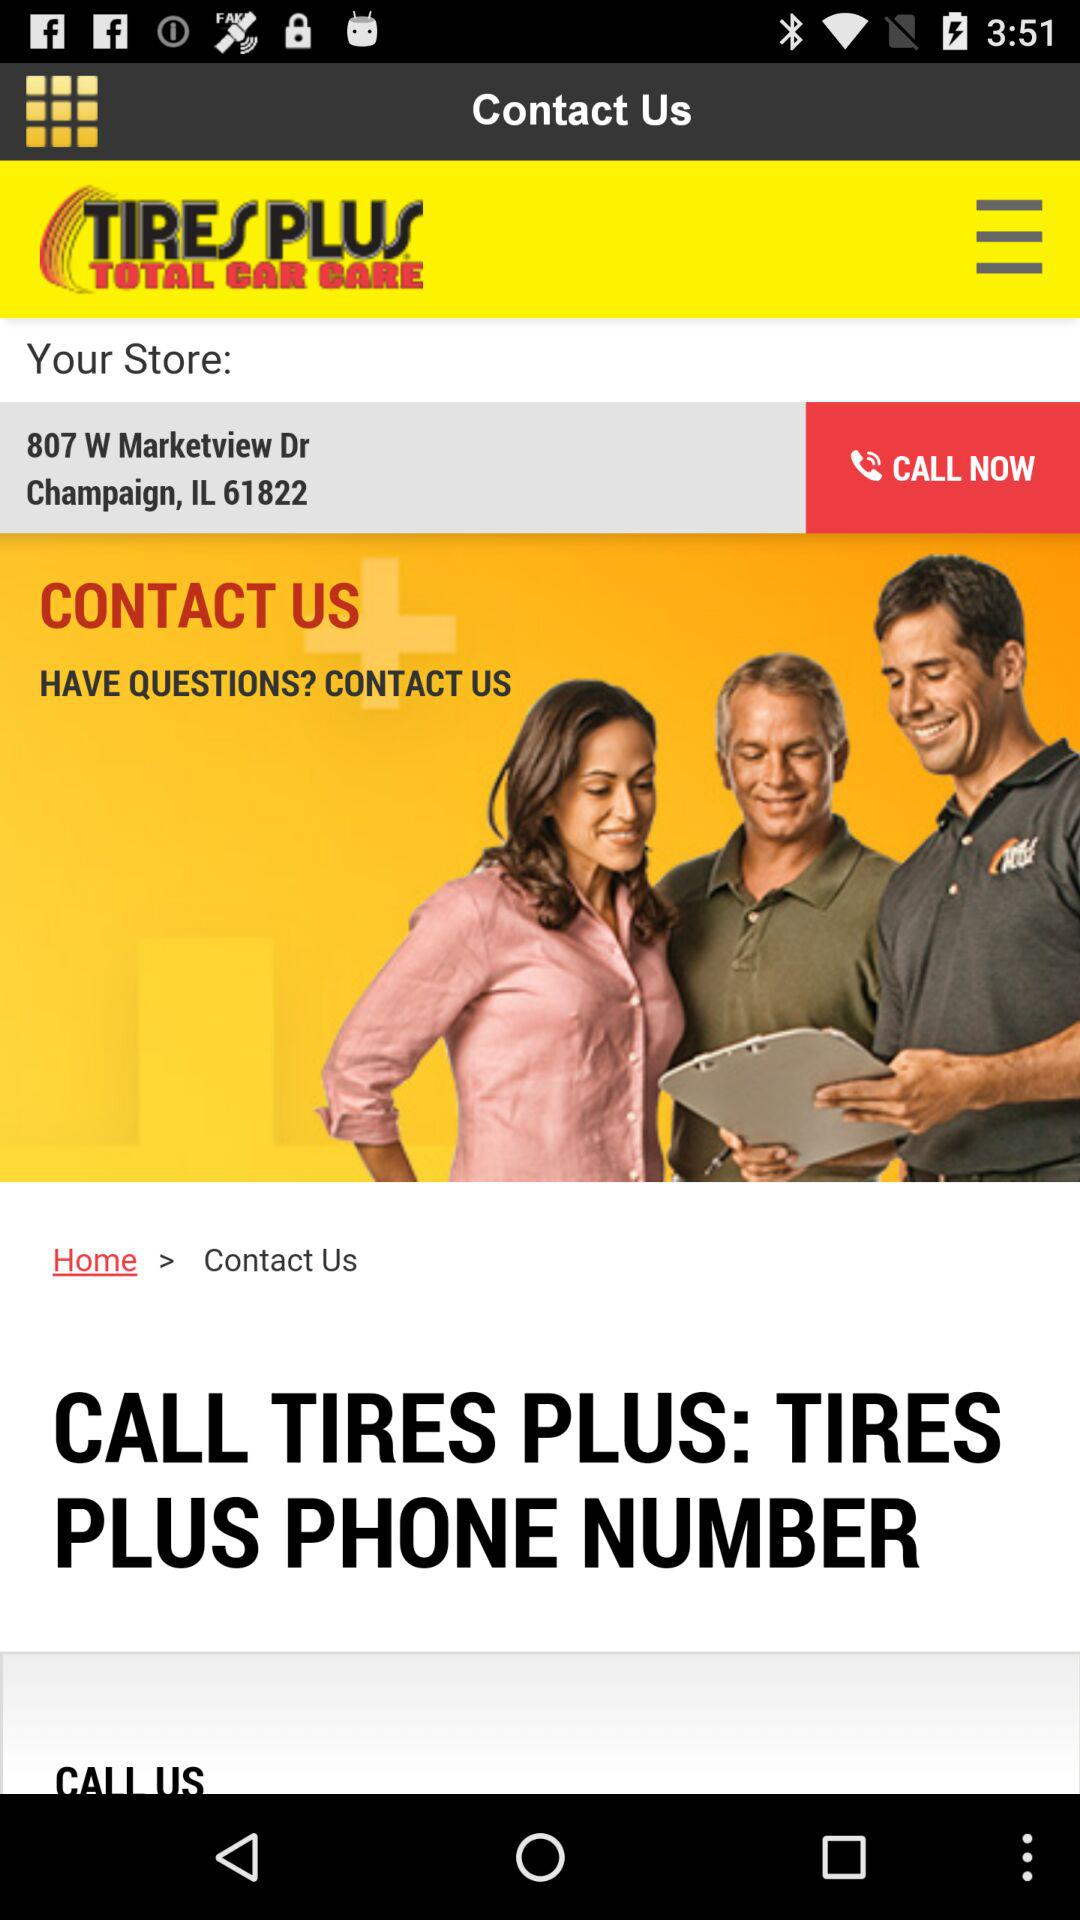What's the address of the store? The address of the store is 807 W Marketview Dr., Champaign, IL 61822. 